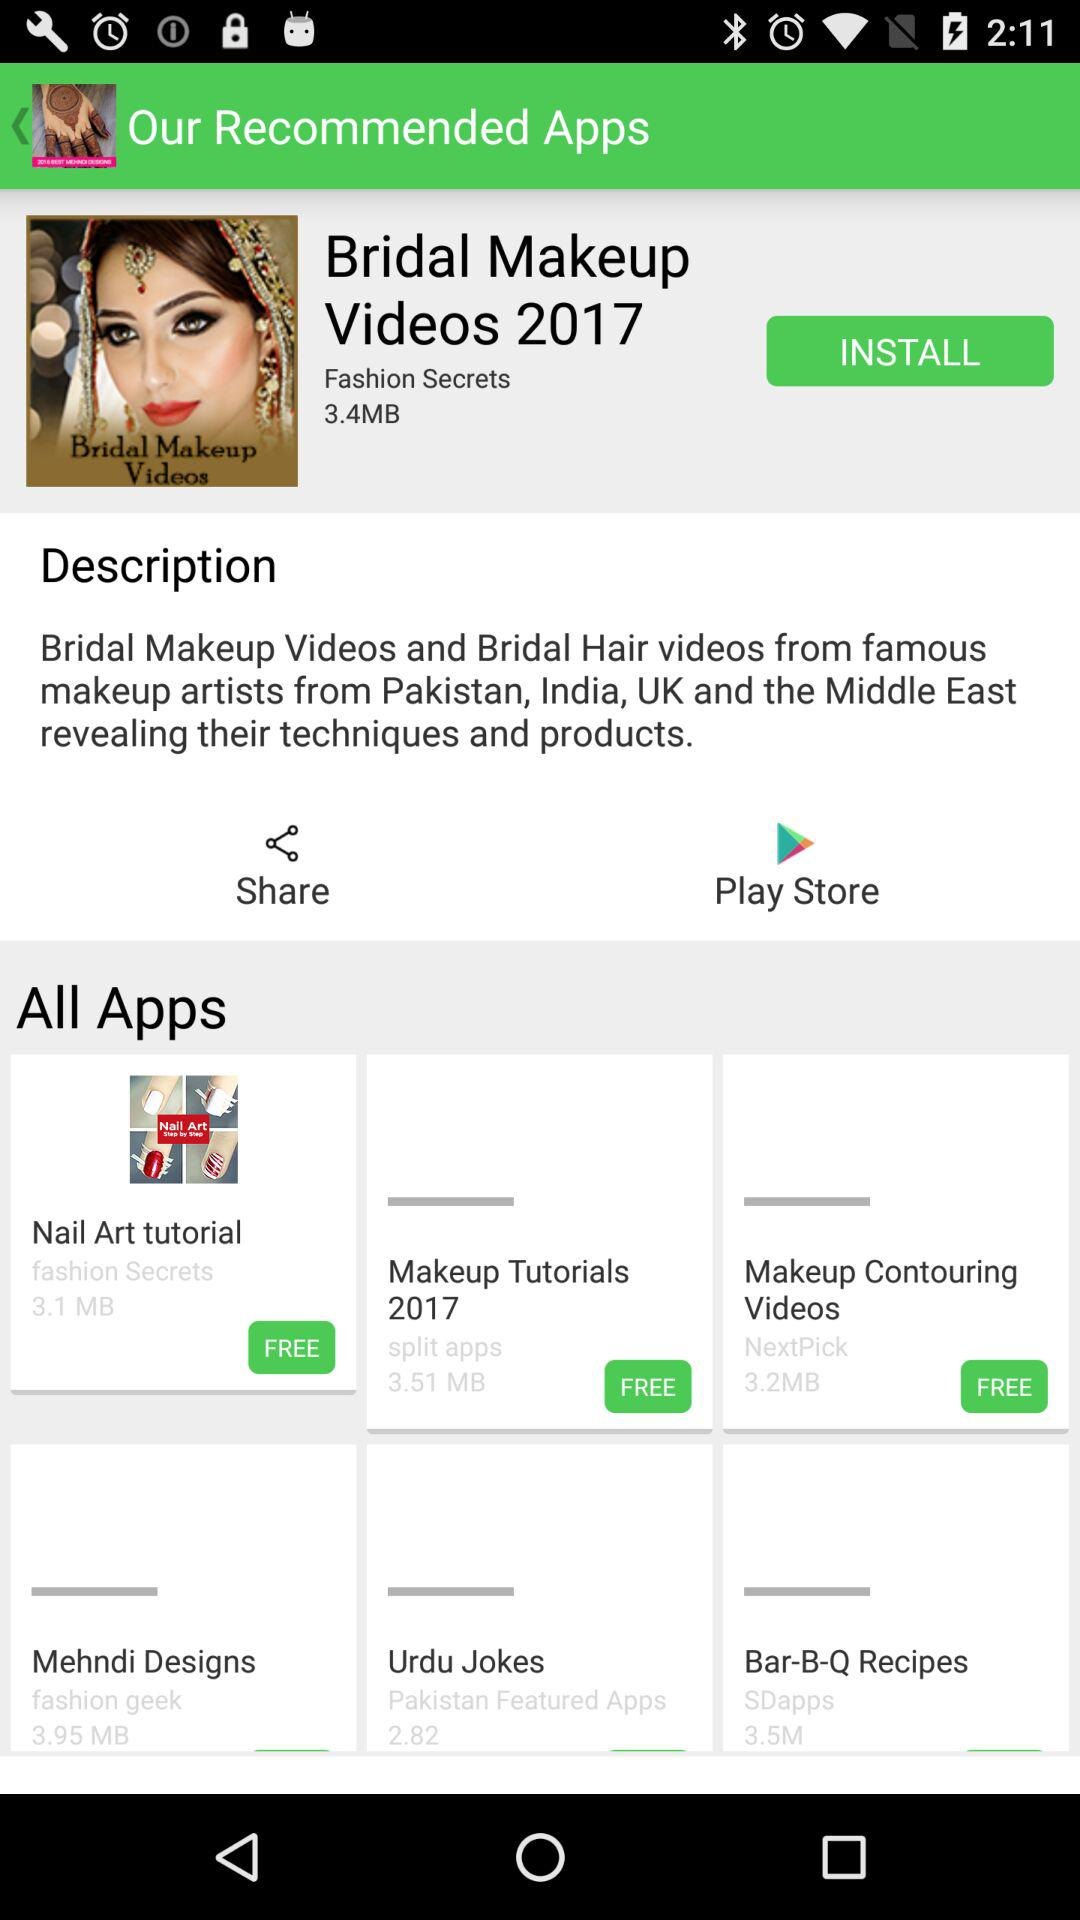How much data is used in "Bridal Makeup Videos 2017"? The data is 3.4 MB. 